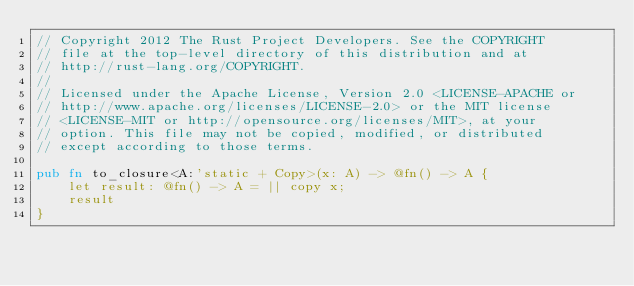<code> <loc_0><loc_0><loc_500><loc_500><_Rust_>// Copyright 2012 The Rust Project Developers. See the COPYRIGHT
// file at the top-level directory of this distribution and at
// http://rust-lang.org/COPYRIGHT.
//
// Licensed under the Apache License, Version 2.0 <LICENSE-APACHE or
// http://www.apache.org/licenses/LICENSE-2.0> or the MIT license
// <LICENSE-MIT or http://opensource.org/licenses/MIT>, at your
// option. This file may not be copied, modified, or distributed
// except according to those terms.

pub fn to_closure<A:'static + Copy>(x: A) -> @fn() -> A {
    let result: @fn() -> A = || copy x;
    result
}
</code> 